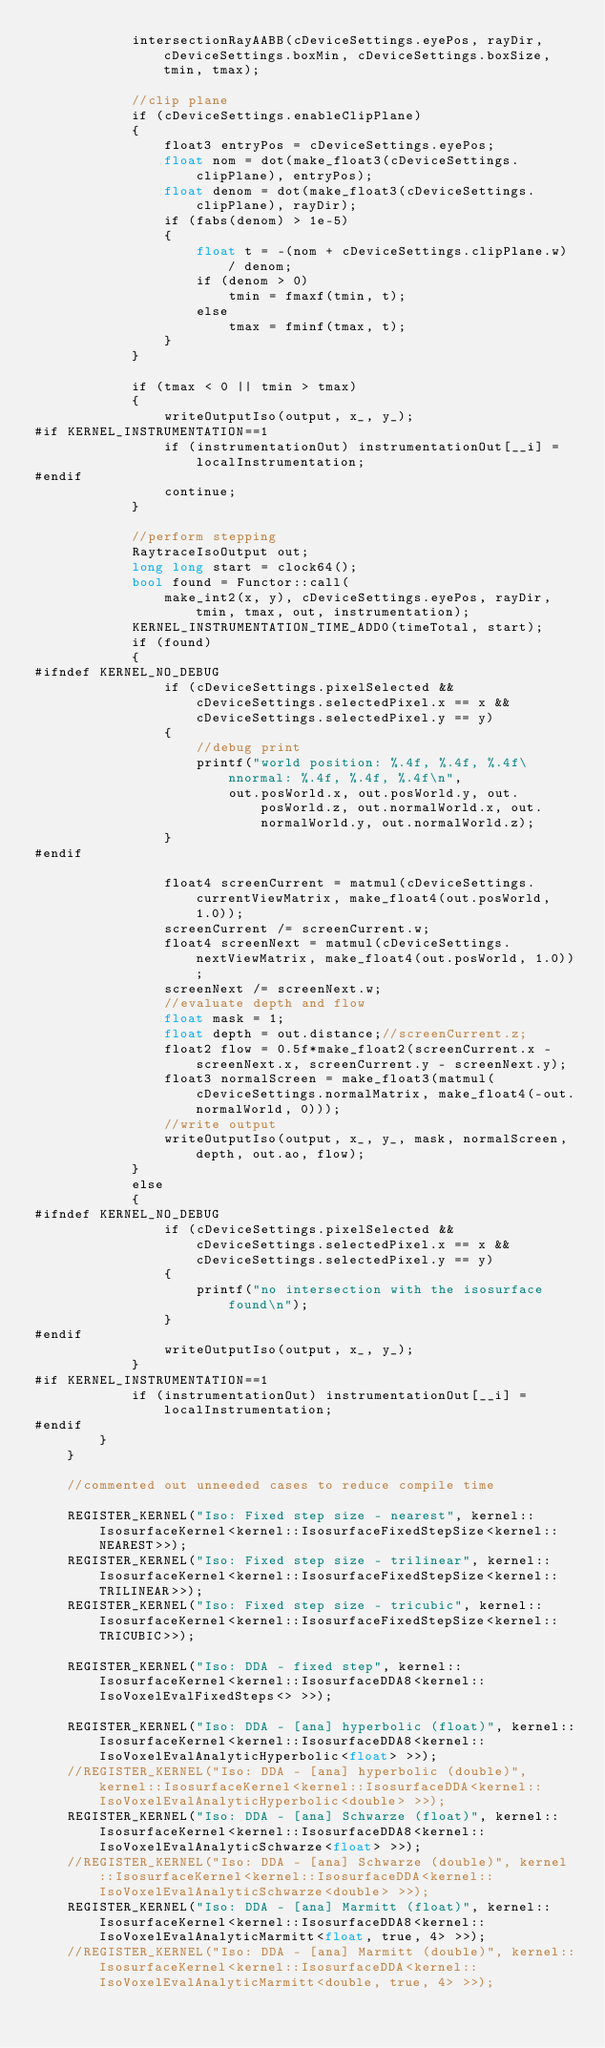Convert code to text. <code><loc_0><loc_0><loc_500><loc_500><_Cuda_>			intersectionRayAABB(cDeviceSettings.eyePos, rayDir, cDeviceSettings.boxMin, cDeviceSettings.boxSize, tmin, tmax);

			//clip plane
			if (cDeviceSettings.enableClipPlane)
			{
				float3 entryPos = cDeviceSettings.eyePos;
				float nom = dot(make_float3(cDeviceSettings.clipPlane), entryPos);
				float denom = dot(make_float3(cDeviceSettings.clipPlane), rayDir);
				if (fabs(denom) > 1e-5)
				{
					float t = -(nom + cDeviceSettings.clipPlane.w) / denom;
					if (denom > 0)
						tmin = fmaxf(tmin, t);
					else
						tmax = fminf(tmax, t);
				}
			}

			if (tmax < 0 || tmin > tmax)
			{
				writeOutputIso(output, x_, y_);
#if KERNEL_INSTRUMENTATION==1
				if (instrumentationOut) instrumentationOut[__i] = localInstrumentation;
#endif
				continue;
			}

			//perform stepping
			RaytraceIsoOutput out;
			long long start = clock64();
			bool found = Functor::call(
				make_int2(x, y), cDeviceSettings.eyePos, rayDir, tmin, tmax, out, instrumentation);
			KERNEL_INSTRUMENTATION_TIME_ADD0(timeTotal, start);
			if (found)
			{
#ifndef KERNEL_NO_DEBUG
				if (cDeviceSettings.pixelSelected && cDeviceSettings.selectedPixel.x == x && cDeviceSettings.selectedPixel.y == y)
				{
					//debug print
					printf("world position: %.4f, %.4f, %.4f\nnormal: %.4f, %.4f, %.4f\n",
						out.posWorld.x, out.posWorld.y, out.posWorld.z, out.normalWorld.x, out.normalWorld.y, out.normalWorld.z);
				}
#endif

				float4 screenCurrent = matmul(cDeviceSettings.currentViewMatrix, make_float4(out.posWorld, 1.0));
				screenCurrent /= screenCurrent.w;
				float4 screenNext = matmul(cDeviceSettings.nextViewMatrix, make_float4(out.posWorld, 1.0));
				screenNext /= screenNext.w;
				//evaluate depth and flow
				float mask = 1;
				float depth = out.distance;//screenCurrent.z;
				float2 flow = 0.5f*make_float2(screenCurrent.x - screenNext.x, screenCurrent.y - screenNext.y);
				float3 normalScreen = make_float3(matmul(cDeviceSettings.normalMatrix, make_float4(-out.normalWorld, 0)));
				//write output
				writeOutputIso(output, x_, y_, mask, normalScreen, depth, out.ao, flow);
			}
			else
			{
#ifndef KERNEL_NO_DEBUG
				if (cDeviceSettings.pixelSelected && cDeviceSettings.selectedPixel.x == x && cDeviceSettings.selectedPixel.y == y)
				{
					printf("no intersection with the isosurface found\n");
				}
#endif
				writeOutputIso(output, x_, y_);
			}
#if KERNEL_INSTRUMENTATION==1
			if (instrumentationOut) instrumentationOut[__i] = localInstrumentation;
#endif
		}
	}

	//commented out unneeded cases to reduce compile time

	REGISTER_KERNEL("Iso: Fixed step size - nearest", kernel::IsosurfaceKernel<kernel::IsosurfaceFixedStepSize<kernel::NEAREST>>);
	REGISTER_KERNEL("Iso: Fixed step size - trilinear", kernel::IsosurfaceKernel<kernel::IsosurfaceFixedStepSize<kernel::TRILINEAR>>);
	REGISTER_KERNEL("Iso: Fixed step size - tricubic", kernel::IsosurfaceKernel<kernel::IsosurfaceFixedStepSize<kernel::TRICUBIC>>);
	
	REGISTER_KERNEL("Iso: DDA - fixed step", kernel::IsosurfaceKernel<kernel::IsosurfaceDDA8<kernel::IsoVoxelEvalFixedSteps<> >>);
	
	REGISTER_KERNEL("Iso: DDA - [ana] hyperbolic (float)", kernel::IsosurfaceKernel<kernel::IsosurfaceDDA8<kernel::IsoVoxelEvalAnalyticHyperbolic<float> >>);
	//REGISTER_KERNEL("Iso: DDA - [ana] hyperbolic (double)", kernel::IsosurfaceKernel<kernel::IsosurfaceDDA<kernel::IsoVoxelEvalAnalyticHyperbolic<double> >>);
	REGISTER_KERNEL("Iso: DDA - [ana] Schwarze (float)", kernel::IsosurfaceKernel<kernel::IsosurfaceDDA8<kernel::IsoVoxelEvalAnalyticSchwarze<float> >>);
	//REGISTER_KERNEL("Iso: DDA - [ana] Schwarze (double)", kernel::IsosurfaceKernel<kernel::IsosurfaceDDA<kernel::IsoVoxelEvalAnalyticSchwarze<double> >>);
	REGISTER_KERNEL("Iso: DDA - [ana] Marmitt (float)", kernel::IsosurfaceKernel<kernel::IsosurfaceDDA8<kernel::IsoVoxelEvalAnalyticMarmitt<float, true, 4> >>);
	//REGISTER_KERNEL("Iso: DDA - [ana] Marmitt (double)", kernel::IsosurfaceKernel<kernel::IsosurfaceDDA<kernel::IsoVoxelEvalAnalyticMarmitt<double, true, 4> >>);
	</code> 